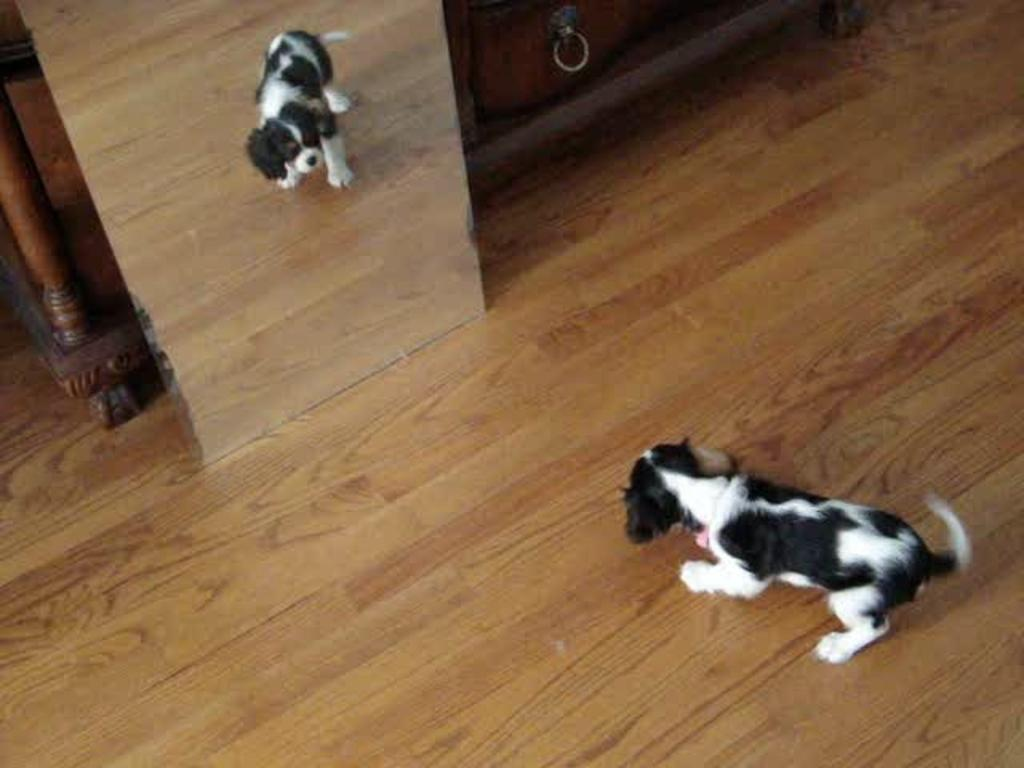What type of animal is in the image? There is a dog in the image. Where is the dog located in the image? The dog is on the floor. What can be seen in the mirror in the image? The dog has a mirror image in the mirror. What furniture is visible in the background of the image? There is a table and a cabinet in the background of the image. What might be the location of the image based on the background? The image may have been taken in a hall, given the presence of a table and cabinet in the background. What is the dog's opinion on the current political climate in the image? The image does not provide any information about the dog's opinion on the current political climate, as it is focused on the dog's physical appearance and location. 